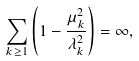Convert formula to latex. <formula><loc_0><loc_0><loc_500><loc_500>\sum _ { k \geq 1 } \left ( 1 - \frac { \mu _ { k } ^ { 2 } } { \lambda _ { k } ^ { 2 } } \right ) = \infty ,</formula> 